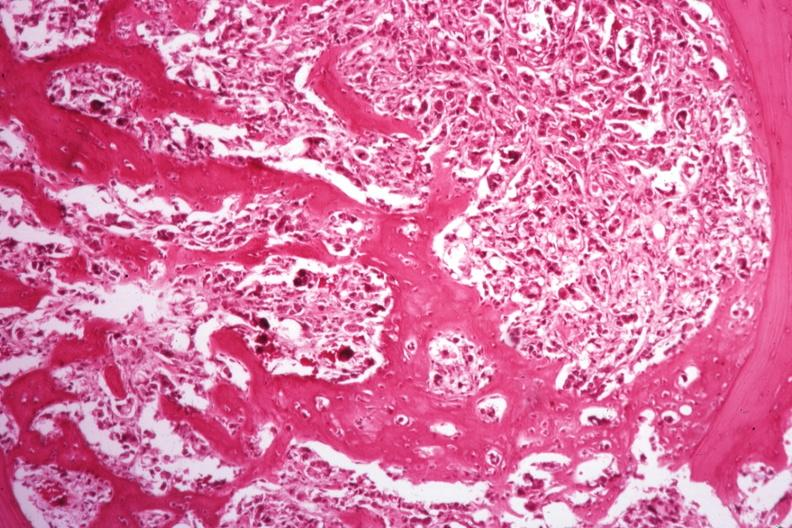what does this image show?
Answer the question using a single word or phrase. Islands of tumor with nice new bone formation 